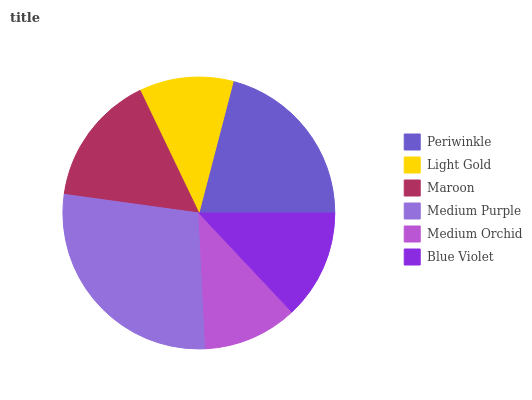Is Light Gold the minimum?
Answer yes or no. Yes. Is Medium Purple the maximum?
Answer yes or no. Yes. Is Maroon the minimum?
Answer yes or no. No. Is Maroon the maximum?
Answer yes or no. No. Is Maroon greater than Light Gold?
Answer yes or no. Yes. Is Light Gold less than Maroon?
Answer yes or no. Yes. Is Light Gold greater than Maroon?
Answer yes or no. No. Is Maroon less than Light Gold?
Answer yes or no. No. Is Maroon the high median?
Answer yes or no. Yes. Is Blue Violet the low median?
Answer yes or no. Yes. Is Periwinkle the high median?
Answer yes or no. No. Is Medium Orchid the low median?
Answer yes or no. No. 